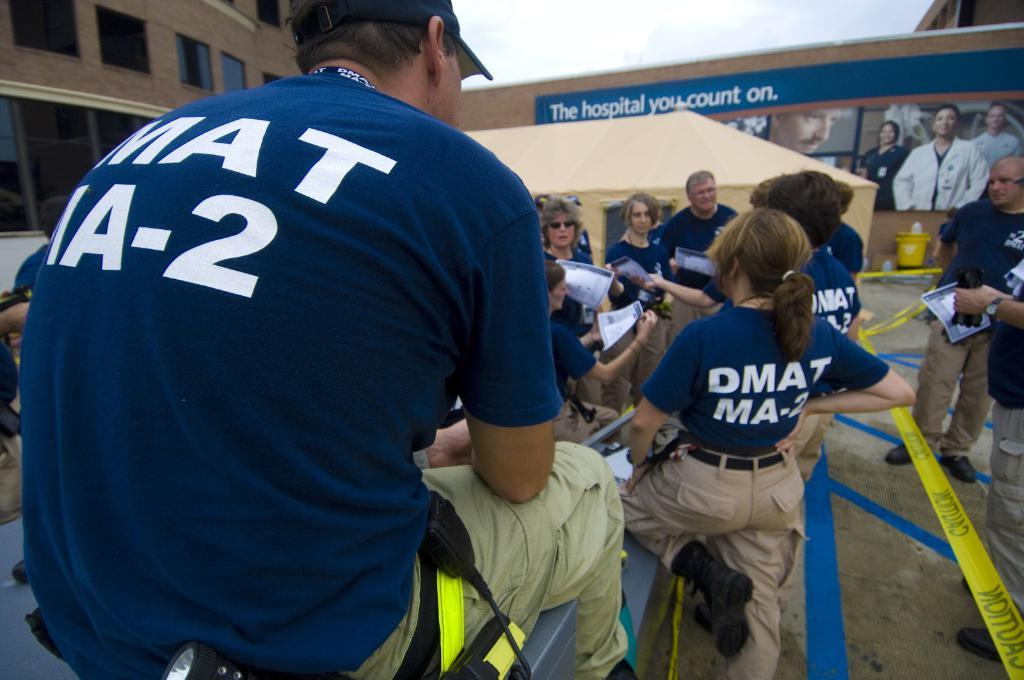<image>
Summarize the visual content of the image. The people pictured are possibly working for a company called DMAT. 